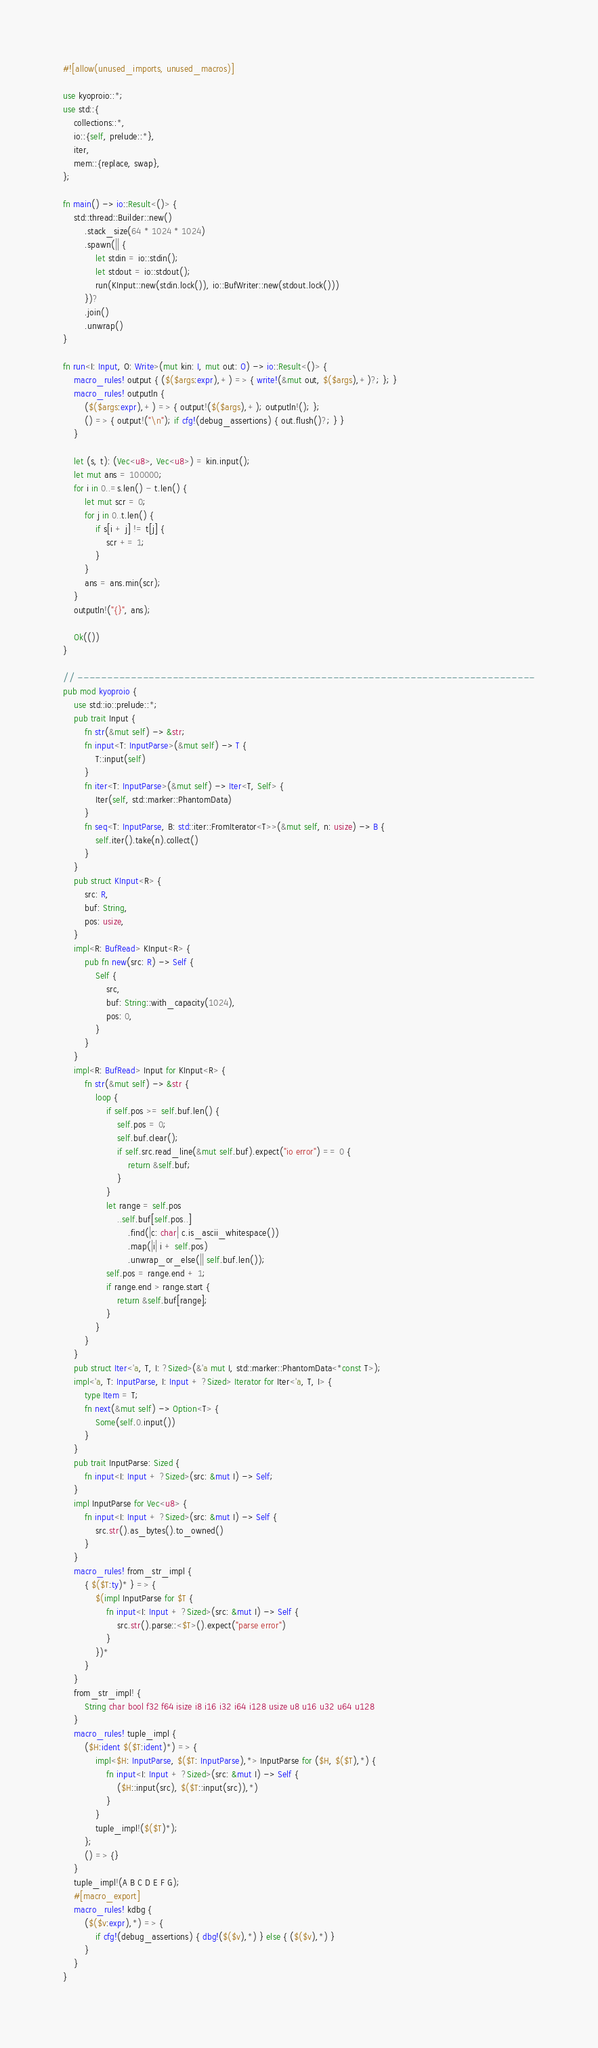Convert code to text. <code><loc_0><loc_0><loc_500><loc_500><_Rust_>#![allow(unused_imports, unused_macros)]

use kyoproio::*;
use std::{
    collections::*,
    io::{self, prelude::*},
    iter,
    mem::{replace, swap},
};

fn main() -> io::Result<()> {
    std::thread::Builder::new()
        .stack_size(64 * 1024 * 1024)
        .spawn(|| {
            let stdin = io::stdin();
            let stdout = io::stdout();
            run(KInput::new(stdin.lock()), io::BufWriter::new(stdout.lock()))
        })?
        .join()
        .unwrap()
}

fn run<I: Input, O: Write>(mut kin: I, mut out: O) -> io::Result<()> {
    macro_rules! output { ($($args:expr),+) => { write!(&mut out, $($args),+)?; }; }
    macro_rules! outputln {
        ($($args:expr),+) => { output!($($args),+); outputln!(); };
        () => { output!("\n"); if cfg!(debug_assertions) { out.flush()?; } }
    }

    let (s, t): (Vec<u8>, Vec<u8>) = kin.input();
    let mut ans = 100000;
    for i in 0..=s.len() - t.len() {
        let mut scr = 0;
        for j in 0..t.len() {
            if s[i + j] != t[j] {
                scr += 1;
            }
        }
        ans = ans.min(scr);
    }
    outputln!("{}", ans);

    Ok(())
}

// -----------------------------------------------------------------------------
pub mod kyoproio {
    use std::io::prelude::*;
    pub trait Input {
        fn str(&mut self) -> &str;
        fn input<T: InputParse>(&mut self) -> T {
            T::input(self)
        }
        fn iter<T: InputParse>(&mut self) -> Iter<T, Self> {
            Iter(self, std::marker::PhantomData)
        }
        fn seq<T: InputParse, B: std::iter::FromIterator<T>>(&mut self, n: usize) -> B {
            self.iter().take(n).collect()
        }
    }
    pub struct KInput<R> {
        src: R,
        buf: String,
        pos: usize,
    }
    impl<R: BufRead> KInput<R> {
        pub fn new(src: R) -> Self {
            Self {
                src,
                buf: String::with_capacity(1024),
                pos: 0,
            }
        }
    }
    impl<R: BufRead> Input for KInput<R> {
        fn str(&mut self) -> &str {
            loop {
                if self.pos >= self.buf.len() {
                    self.pos = 0;
                    self.buf.clear();
                    if self.src.read_line(&mut self.buf).expect("io error") == 0 {
                        return &self.buf;
                    }
                }
                let range = self.pos
                    ..self.buf[self.pos..]
                        .find(|c: char| c.is_ascii_whitespace())
                        .map(|i| i + self.pos)
                        .unwrap_or_else(|| self.buf.len());
                self.pos = range.end + 1;
                if range.end > range.start {
                    return &self.buf[range];
                }
            }
        }
    }
    pub struct Iter<'a, T, I: ?Sized>(&'a mut I, std::marker::PhantomData<*const T>);
    impl<'a, T: InputParse, I: Input + ?Sized> Iterator for Iter<'a, T, I> {
        type Item = T;
        fn next(&mut self) -> Option<T> {
            Some(self.0.input())
        }
    }
    pub trait InputParse: Sized {
        fn input<I: Input + ?Sized>(src: &mut I) -> Self;
    }
    impl InputParse for Vec<u8> {
        fn input<I: Input + ?Sized>(src: &mut I) -> Self {
            src.str().as_bytes().to_owned()
        }
    }
    macro_rules! from_str_impl {
        { $($T:ty)* } => {
            $(impl InputParse for $T {
                fn input<I: Input + ?Sized>(src: &mut I) -> Self {
                    src.str().parse::<$T>().expect("parse error")
                }
            })*
        }
    }
    from_str_impl! {
        String char bool f32 f64 isize i8 i16 i32 i64 i128 usize u8 u16 u32 u64 u128
    }
    macro_rules! tuple_impl {
        ($H:ident $($T:ident)*) => {
            impl<$H: InputParse, $($T: InputParse),*> InputParse for ($H, $($T),*) {
                fn input<I: Input + ?Sized>(src: &mut I) -> Self {
                    ($H::input(src), $($T::input(src)),*)
                }
            }
            tuple_impl!($($T)*);
        };
        () => {}
    }
    tuple_impl!(A B C D E F G);
    #[macro_export]
    macro_rules! kdbg {
        ($($v:expr),*) => {
            if cfg!(debug_assertions) { dbg!($($v),*) } else { ($($v),*) }
        }
    }
}
</code> 